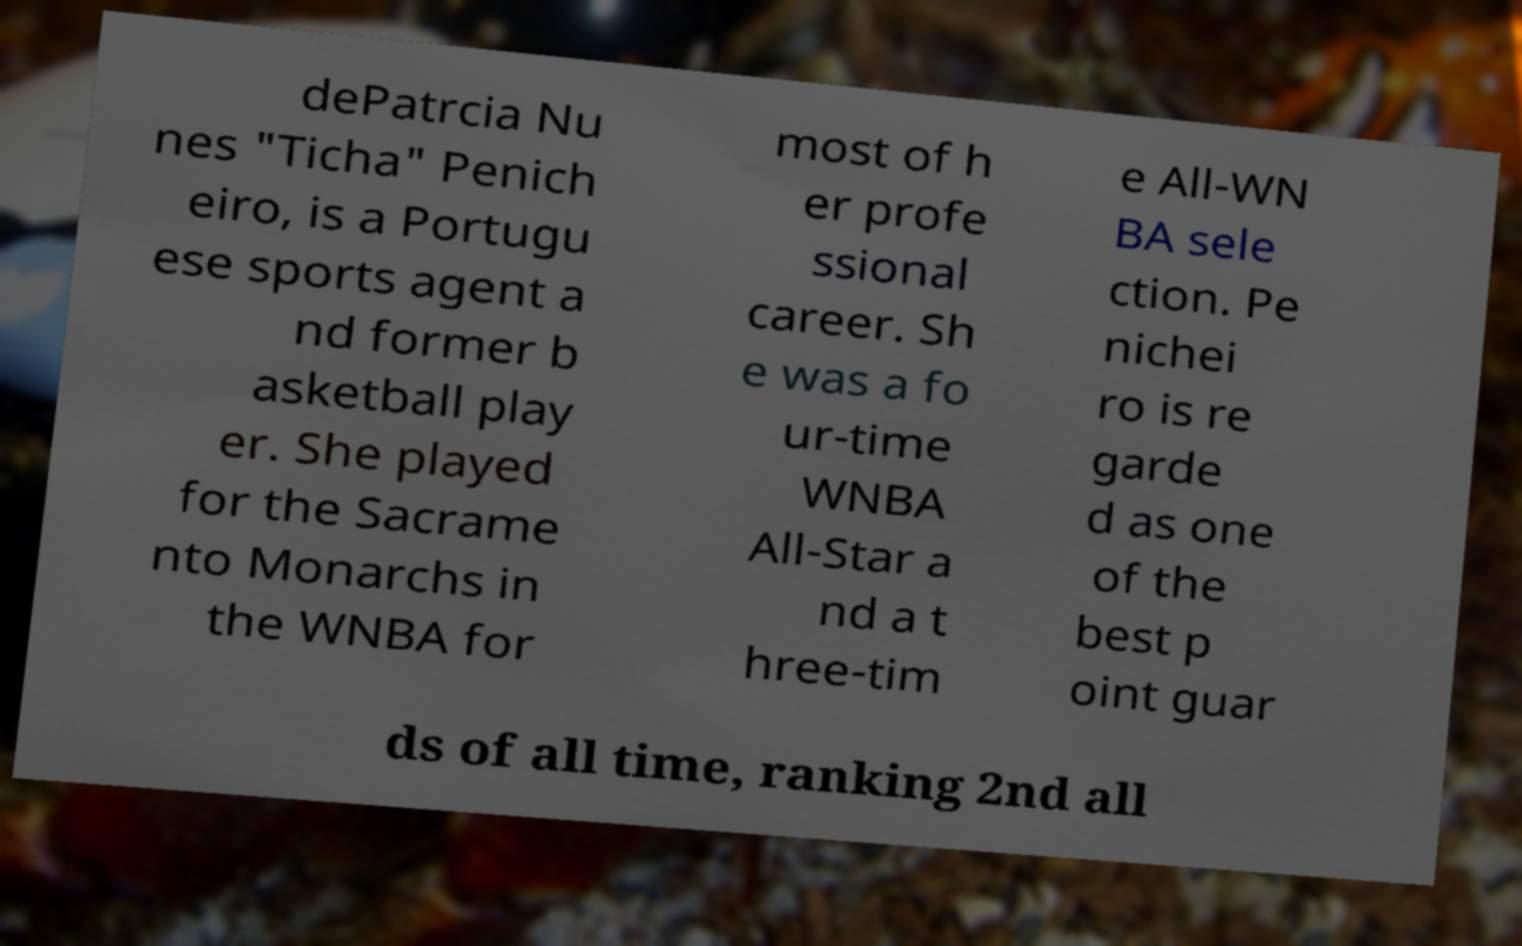For documentation purposes, I need the text within this image transcribed. Could you provide that? dePatrcia Nu nes "Ticha" Penich eiro, is a Portugu ese sports agent a nd former b asketball play er. She played for the Sacrame nto Monarchs in the WNBA for most of h er profe ssional career. Sh e was a fo ur-time WNBA All-Star a nd a t hree-tim e All-WN BA sele ction. Pe nichei ro is re garde d as one of the best p oint guar ds of all time, ranking 2nd all 